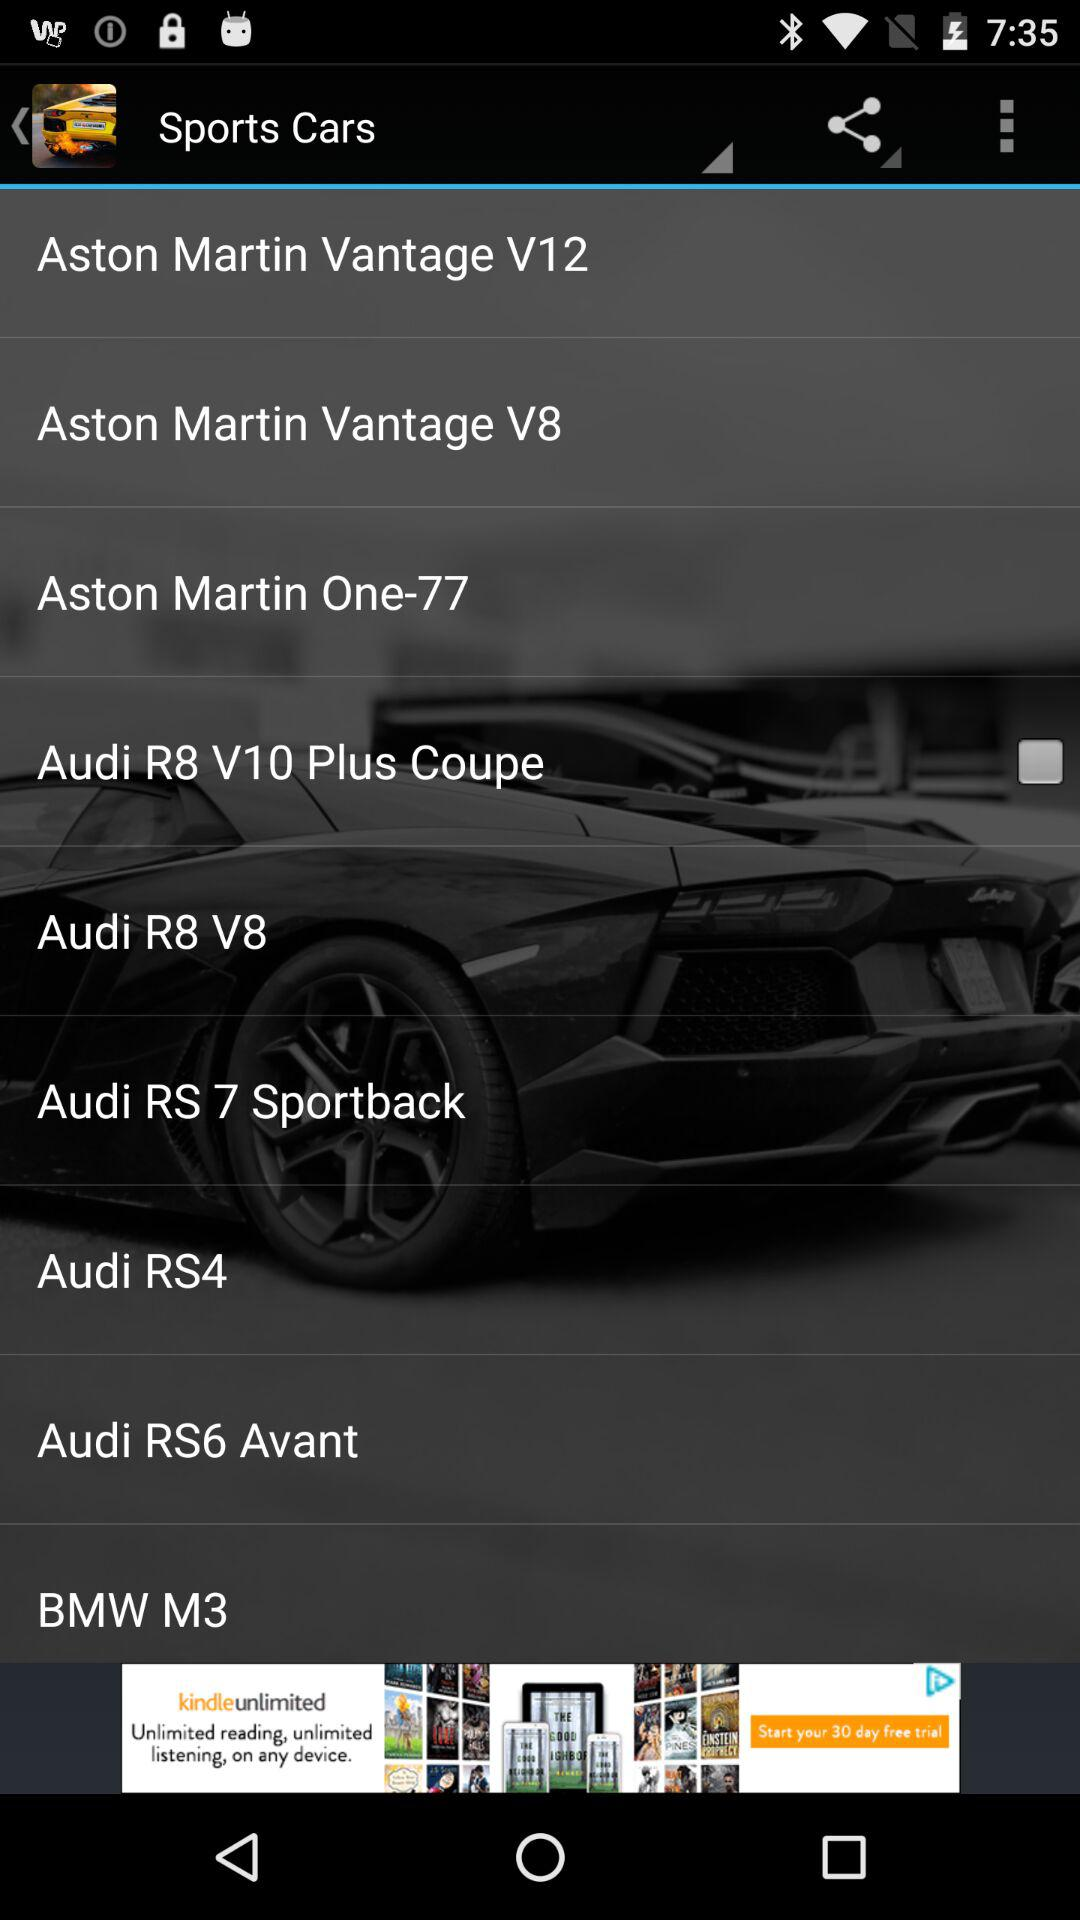What is the model of the "Aston Martin Vantage" car? The models of the "Aston Martin Vantage" car are "V12" and "V8". 